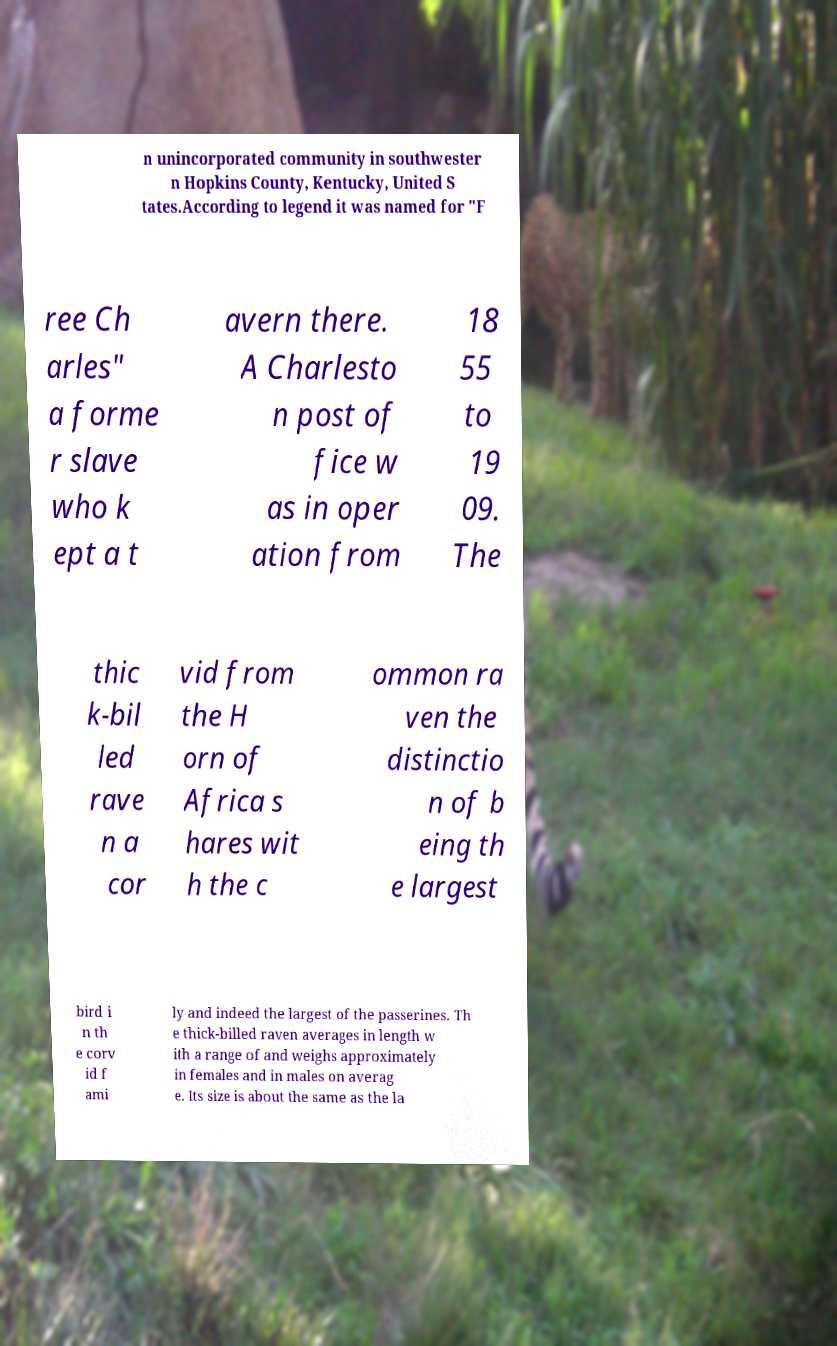Can you accurately transcribe the text from the provided image for me? n unincorporated community in southwester n Hopkins County, Kentucky, United S tates.According to legend it was named for "F ree Ch arles" a forme r slave who k ept a t avern there. A Charlesto n post of fice w as in oper ation from 18 55 to 19 09. The thic k-bil led rave n a cor vid from the H orn of Africa s hares wit h the c ommon ra ven the distinctio n of b eing th e largest bird i n th e corv id f ami ly and indeed the largest of the passerines. Th e thick-billed raven averages in length w ith a range of and weighs approximately in females and in males on averag e. Its size is about the same as the la 